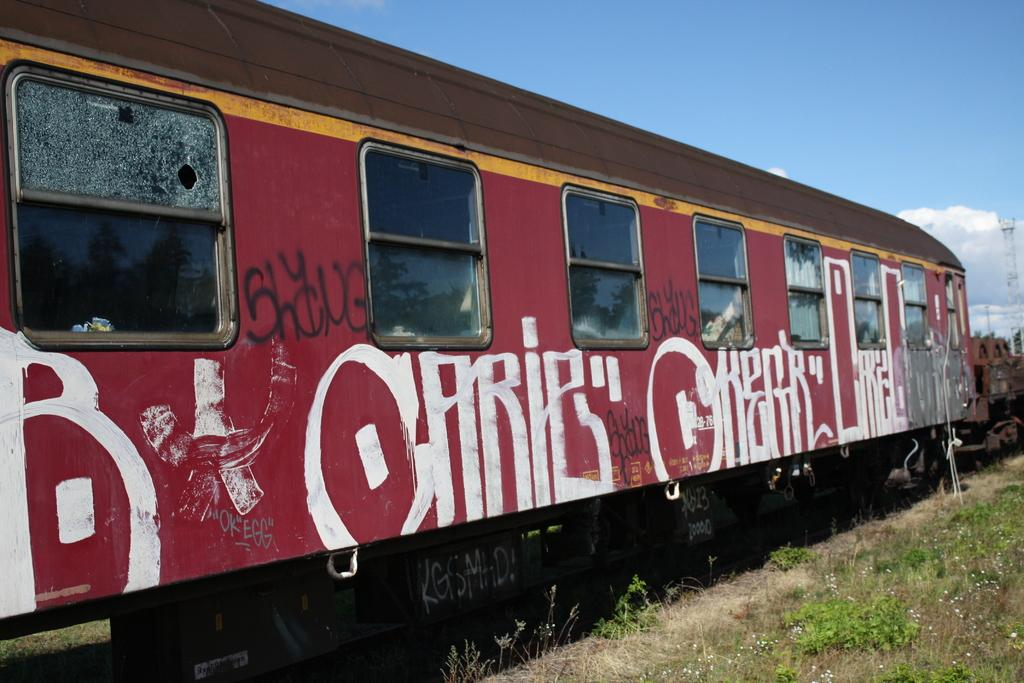What type of train compartment is shown in the image? There is a compartment coach in the image. What can be seen on the exterior of the compartment coach? The compartment coach has graffiti on it. What feature allows passengers to see outside the compartment coach? The compartment coach has windows. What structure is located on the right side of the image? There is a tower on the right side of the image. What is visible in the background of the image? The sky is visible in the image. How many beams are supporting the tower in the image? There is no information about beams or the tower's support structure in the image. Are there any spiders crawling on the compartment coach in the image? There is no mention of spiders or any living creatures on the compartment coach in the image. 